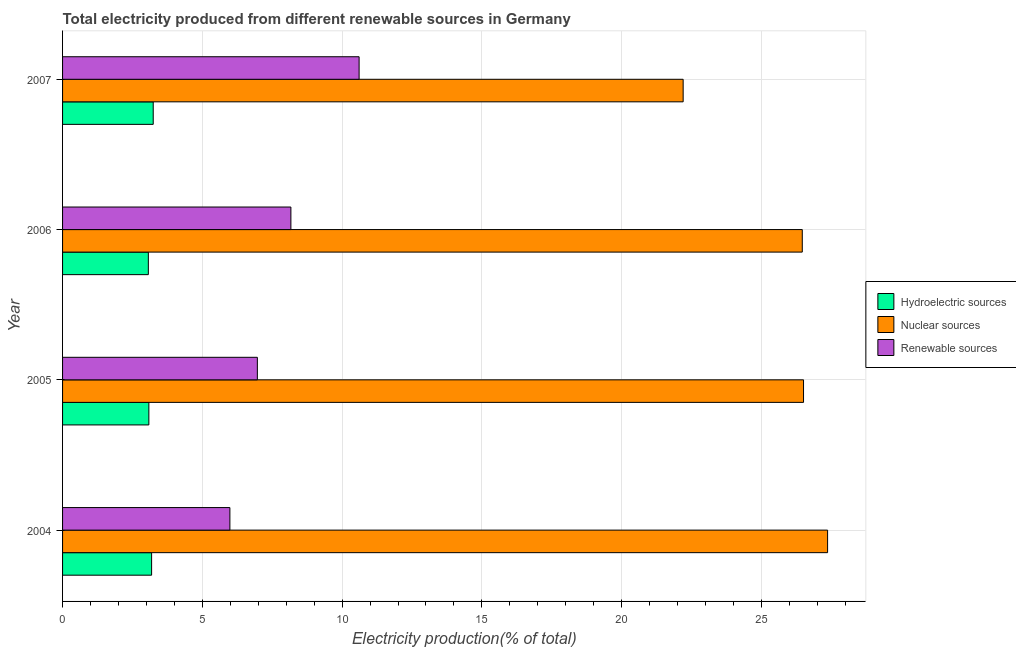Are the number of bars on each tick of the Y-axis equal?
Ensure brevity in your answer.  Yes. How many bars are there on the 4th tick from the top?
Make the answer very short. 3. How many bars are there on the 4th tick from the bottom?
Your response must be concise. 3. What is the label of the 2nd group of bars from the top?
Provide a short and direct response. 2006. In how many cases, is the number of bars for a given year not equal to the number of legend labels?
Ensure brevity in your answer.  0. What is the percentage of electricity produced by nuclear sources in 2006?
Make the answer very short. 26.46. Across all years, what is the maximum percentage of electricity produced by hydroelectric sources?
Give a very brief answer. 3.24. Across all years, what is the minimum percentage of electricity produced by hydroelectric sources?
Provide a short and direct response. 3.07. In which year was the percentage of electricity produced by hydroelectric sources minimum?
Make the answer very short. 2006. What is the total percentage of electricity produced by renewable sources in the graph?
Make the answer very short. 31.73. What is the difference between the percentage of electricity produced by nuclear sources in 2004 and that in 2007?
Offer a terse response. 5.17. What is the difference between the percentage of electricity produced by renewable sources in 2006 and the percentage of electricity produced by nuclear sources in 2004?
Make the answer very short. -19.2. What is the average percentage of electricity produced by renewable sources per year?
Keep it short and to the point. 7.93. In the year 2006, what is the difference between the percentage of electricity produced by nuclear sources and percentage of electricity produced by renewable sources?
Provide a short and direct response. 18.29. What is the ratio of the percentage of electricity produced by renewable sources in 2004 to that in 2007?
Your answer should be very brief. 0.56. Is the difference between the percentage of electricity produced by hydroelectric sources in 2005 and 2006 greater than the difference between the percentage of electricity produced by nuclear sources in 2005 and 2006?
Provide a succinct answer. No. What is the difference between the highest and the second highest percentage of electricity produced by nuclear sources?
Make the answer very short. 0.86. What is the difference between the highest and the lowest percentage of electricity produced by renewable sources?
Keep it short and to the point. 4.62. What does the 3rd bar from the top in 2006 represents?
Offer a very short reply. Hydroelectric sources. What does the 3rd bar from the bottom in 2006 represents?
Provide a short and direct response. Renewable sources. Is it the case that in every year, the sum of the percentage of electricity produced by hydroelectric sources and percentage of electricity produced by nuclear sources is greater than the percentage of electricity produced by renewable sources?
Ensure brevity in your answer.  Yes. Are all the bars in the graph horizontal?
Provide a short and direct response. Yes. How many years are there in the graph?
Keep it short and to the point. 4. Does the graph contain grids?
Keep it short and to the point. Yes. How are the legend labels stacked?
Make the answer very short. Vertical. What is the title of the graph?
Offer a very short reply. Total electricity produced from different renewable sources in Germany. What is the label or title of the Y-axis?
Your answer should be very brief. Year. What is the Electricity production(% of total) in Hydroelectric sources in 2004?
Your answer should be very brief. 3.19. What is the Electricity production(% of total) in Nuclear sources in 2004?
Offer a very short reply. 27.37. What is the Electricity production(% of total) of Renewable sources in 2004?
Offer a very short reply. 5.99. What is the Electricity production(% of total) in Hydroelectric sources in 2005?
Your answer should be compact. 3.09. What is the Electricity production(% of total) of Nuclear sources in 2005?
Your response must be concise. 26.51. What is the Electricity production(% of total) of Renewable sources in 2005?
Your answer should be very brief. 6.97. What is the Electricity production(% of total) in Hydroelectric sources in 2006?
Your answer should be very brief. 3.07. What is the Electricity production(% of total) in Nuclear sources in 2006?
Your response must be concise. 26.46. What is the Electricity production(% of total) of Renewable sources in 2006?
Provide a short and direct response. 8.17. What is the Electricity production(% of total) of Hydroelectric sources in 2007?
Your response must be concise. 3.24. What is the Electricity production(% of total) of Nuclear sources in 2007?
Offer a very short reply. 22.2. What is the Electricity production(% of total) of Renewable sources in 2007?
Ensure brevity in your answer.  10.61. Across all years, what is the maximum Electricity production(% of total) of Hydroelectric sources?
Offer a terse response. 3.24. Across all years, what is the maximum Electricity production(% of total) of Nuclear sources?
Keep it short and to the point. 27.37. Across all years, what is the maximum Electricity production(% of total) in Renewable sources?
Offer a very short reply. 10.61. Across all years, what is the minimum Electricity production(% of total) of Hydroelectric sources?
Keep it short and to the point. 3.07. Across all years, what is the minimum Electricity production(% of total) of Nuclear sources?
Keep it short and to the point. 22.2. Across all years, what is the minimum Electricity production(% of total) of Renewable sources?
Your response must be concise. 5.99. What is the total Electricity production(% of total) in Hydroelectric sources in the graph?
Provide a short and direct response. 12.58. What is the total Electricity production(% of total) of Nuclear sources in the graph?
Offer a terse response. 102.54. What is the total Electricity production(% of total) of Renewable sources in the graph?
Give a very brief answer. 31.73. What is the difference between the Electricity production(% of total) in Hydroelectric sources in 2004 and that in 2005?
Give a very brief answer. 0.1. What is the difference between the Electricity production(% of total) of Nuclear sources in 2004 and that in 2005?
Offer a very short reply. 0.86. What is the difference between the Electricity production(% of total) in Renewable sources in 2004 and that in 2005?
Your response must be concise. -0.98. What is the difference between the Electricity production(% of total) in Hydroelectric sources in 2004 and that in 2006?
Give a very brief answer. 0.12. What is the difference between the Electricity production(% of total) of Nuclear sources in 2004 and that in 2006?
Provide a succinct answer. 0.91. What is the difference between the Electricity production(% of total) of Renewable sources in 2004 and that in 2006?
Your response must be concise. -2.18. What is the difference between the Electricity production(% of total) in Hydroelectric sources in 2004 and that in 2007?
Provide a short and direct response. -0.06. What is the difference between the Electricity production(% of total) in Nuclear sources in 2004 and that in 2007?
Your answer should be compact. 5.17. What is the difference between the Electricity production(% of total) of Renewable sources in 2004 and that in 2007?
Provide a short and direct response. -4.62. What is the difference between the Electricity production(% of total) of Hydroelectric sources in 2005 and that in 2006?
Your response must be concise. 0.02. What is the difference between the Electricity production(% of total) in Nuclear sources in 2005 and that in 2006?
Give a very brief answer. 0.04. What is the difference between the Electricity production(% of total) of Renewable sources in 2005 and that in 2006?
Provide a short and direct response. -1.2. What is the difference between the Electricity production(% of total) in Hydroelectric sources in 2005 and that in 2007?
Your answer should be compact. -0.16. What is the difference between the Electricity production(% of total) in Nuclear sources in 2005 and that in 2007?
Give a very brief answer. 4.31. What is the difference between the Electricity production(% of total) in Renewable sources in 2005 and that in 2007?
Provide a succinct answer. -3.64. What is the difference between the Electricity production(% of total) of Hydroelectric sources in 2006 and that in 2007?
Keep it short and to the point. -0.17. What is the difference between the Electricity production(% of total) in Nuclear sources in 2006 and that in 2007?
Ensure brevity in your answer.  4.26. What is the difference between the Electricity production(% of total) of Renewable sources in 2006 and that in 2007?
Your answer should be very brief. -2.44. What is the difference between the Electricity production(% of total) of Hydroelectric sources in 2004 and the Electricity production(% of total) of Nuclear sources in 2005?
Offer a very short reply. -23.32. What is the difference between the Electricity production(% of total) in Hydroelectric sources in 2004 and the Electricity production(% of total) in Renewable sources in 2005?
Your answer should be compact. -3.78. What is the difference between the Electricity production(% of total) in Nuclear sources in 2004 and the Electricity production(% of total) in Renewable sources in 2005?
Your answer should be very brief. 20.4. What is the difference between the Electricity production(% of total) of Hydroelectric sources in 2004 and the Electricity production(% of total) of Nuclear sources in 2006?
Offer a very short reply. -23.28. What is the difference between the Electricity production(% of total) in Hydroelectric sources in 2004 and the Electricity production(% of total) in Renewable sources in 2006?
Ensure brevity in your answer.  -4.98. What is the difference between the Electricity production(% of total) in Nuclear sources in 2004 and the Electricity production(% of total) in Renewable sources in 2006?
Give a very brief answer. 19.2. What is the difference between the Electricity production(% of total) of Hydroelectric sources in 2004 and the Electricity production(% of total) of Nuclear sources in 2007?
Your answer should be very brief. -19.01. What is the difference between the Electricity production(% of total) in Hydroelectric sources in 2004 and the Electricity production(% of total) in Renewable sources in 2007?
Your answer should be very brief. -7.42. What is the difference between the Electricity production(% of total) in Nuclear sources in 2004 and the Electricity production(% of total) in Renewable sources in 2007?
Keep it short and to the point. 16.76. What is the difference between the Electricity production(% of total) of Hydroelectric sources in 2005 and the Electricity production(% of total) of Nuclear sources in 2006?
Make the answer very short. -23.37. What is the difference between the Electricity production(% of total) of Hydroelectric sources in 2005 and the Electricity production(% of total) of Renewable sources in 2006?
Keep it short and to the point. -5.08. What is the difference between the Electricity production(% of total) in Nuclear sources in 2005 and the Electricity production(% of total) in Renewable sources in 2006?
Your response must be concise. 18.34. What is the difference between the Electricity production(% of total) in Hydroelectric sources in 2005 and the Electricity production(% of total) in Nuclear sources in 2007?
Ensure brevity in your answer.  -19.11. What is the difference between the Electricity production(% of total) in Hydroelectric sources in 2005 and the Electricity production(% of total) in Renewable sources in 2007?
Your answer should be very brief. -7.52. What is the difference between the Electricity production(% of total) of Nuclear sources in 2005 and the Electricity production(% of total) of Renewable sources in 2007?
Your answer should be very brief. 15.9. What is the difference between the Electricity production(% of total) in Hydroelectric sources in 2006 and the Electricity production(% of total) in Nuclear sources in 2007?
Ensure brevity in your answer.  -19.13. What is the difference between the Electricity production(% of total) in Hydroelectric sources in 2006 and the Electricity production(% of total) in Renewable sources in 2007?
Your response must be concise. -7.54. What is the difference between the Electricity production(% of total) of Nuclear sources in 2006 and the Electricity production(% of total) of Renewable sources in 2007?
Keep it short and to the point. 15.85. What is the average Electricity production(% of total) of Hydroelectric sources per year?
Offer a very short reply. 3.15. What is the average Electricity production(% of total) in Nuclear sources per year?
Provide a short and direct response. 25.63. What is the average Electricity production(% of total) of Renewable sources per year?
Your answer should be compact. 7.93. In the year 2004, what is the difference between the Electricity production(% of total) in Hydroelectric sources and Electricity production(% of total) in Nuclear sources?
Provide a succinct answer. -24.18. In the year 2004, what is the difference between the Electricity production(% of total) of Hydroelectric sources and Electricity production(% of total) of Renewable sources?
Give a very brief answer. -2.8. In the year 2004, what is the difference between the Electricity production(% of total) in Nuclear sources and Electricity production(% of total) in Renewable sources?
Make the answer very short. 21.38. In the year 2005, what is the difference between the Electricity production(% of total) in Hydroelectric sources and Electricity production(% of total) in Nuclear sources?
Your answer should be very brief. -23.42. In the year 2005, what is the difference between the Electricity production(% of total) of Hydroelectric sources and Electricity production(% of total) of Renewable sources?
Give a very brief answer. -3.88. In the year 2005, what is the difference between the Electricity production(% of total) in Nuclear sources and Electricity production(% of total) in Renewable sources?
Ensure brevity in your answer.  19.54. In the year 2006, what is the difference between the Electricity production(% of total) of Hydroelectric sources and Electricity production(% of total) of Nuclear sources?
Offer a very short reply. -23.39. In the year 2006, what is the difference between the Electricity production(% of total) in Hydroelectric sources and Electricity production(% of total) in Renewable sources?
Ensure brevity in your answer.  -5.1. In the year 2006, what is the difference between the Electricity production(% of total) of Nuclear sources and Electricity production(% of total) of Renewable sources?
Give a very brief answer. 18.29. In the year 2007, what is the difference between the Electricity production(% of total) in Hydroelectric sources and Electricity production(% of total) in Nuclear sources?
Your answer should be very brief. -18.96. In the year 2007, what is the difference between the Electricity production(% of total) of Hydroelectric sources and Electricity production(% of total) of Renewable sources?
Your answer should be compact. -7.36. In the year 2007, what is the difference between the Electricity production(% of total) in Nuclear sources and Electricity production(% of total) in Renewable sources?
Make the answer very short. 11.59. What is the ratio of the Electricity production(% of total) of Hydroelectric sources in 2004 to that in 2005?
Make the answer very short. 1.03. What is the ratio of the Electricity production(% of total) of Nuclear sources in 2004 to that in 2005?
Your answer should be compact. 1.03. What is the ratio of the Electricity production(% of total) of Renewable sources in 2004 to that in 2005?
Make the answer very short. 0.86. What is the ratio of the Electricity production(% of total) of Hydroelectric sources in 2004 to that in 2006?
Offer a very short reply. 1.04. What is the ratio of the Electricity production(% of total) in Nuclear sources in 2004 to that in 2006?
Your answer should be very brief. 1.03. What is the ratio of the Electricity production(% of total) in Renewable sources in 2004 to that in 2006?
Your answer should be compact. 0.73. What is the ratio of the Electricity production(% of total) in Hydroelectric sources in 2004 to that in 2007?
Make the answer very short. 0.98. What is the ratio of the Electricity production(% of total) in Nuclear sources in 2004 to that in 2007?
Make the answer very short. 1.23. What is the ratio of the Electricity production(% of total) of Renewable sources in 2004 to that in 2007?
Offer a terse response. 0.56. What is the ratio of the Electricity production(% of total) in Nuclear sources in 2005 to that in 2006?
Your answer should be very brief. 1. What is the ratio of the Electricity production(% of total) of Renewable sources in 2005 to that in 2006?
Provide a succinct answer. 0.85. What is the ratio of the Electricity production(% of total) in Hydroelectric sources in 2005 to that in 2007?
Your response must be concise. 0.95. What is the ratio of the Electricity production(% of total) in Nuclear sources in 2005 to that in 2007?
Offer a very short reply. 1.19. What is the ratio of the Electricity production(% of total) of Renewable sources in 2005 to that in 2007?
Your answer should be compact. 0.66. What is the ratio of the Electricity production(% of total) in Hydroelectric sources in 2006 to that in 2007?
Your answer should be very brief. 0.95. What is the ratio of the Electricity production(% of total) of Nuclear sources in 2006 to that in 2007?
Ensure brevity in your answer.  1.19. What is the ratio of the Electricity production(% of total) in Renewable sources in 2006 to that in 2007?
Ensure brevity in your answer.  0.77. What is the difference between the highest and the second highest Electricity production(% of total) of Hydroelectric sources?
Provide a succinct answer. 0.06. What is the difference between the highest and the second highest Electricity production(% of total) of Nuclear sources?
Give a very brief answer. 0.86. What is the difference between the highest and the second highest Electricity production(% of total) of Renewable sources?
Your answer should be very brief. 2.44. What is the difference between the highest and the lowest Electricity production(% of total) in Hydroelectric sources?
Offer a terse response. 0.17. What is the difference between the highest and the lowest Electricity production(% of total) of Nuclear sources?
Keep it short and to the point. 5.17. What is the difference between the highest and the lowest Electricity production(% of total) of Renewable sources?
Keep it short and to the point. 4.62. 